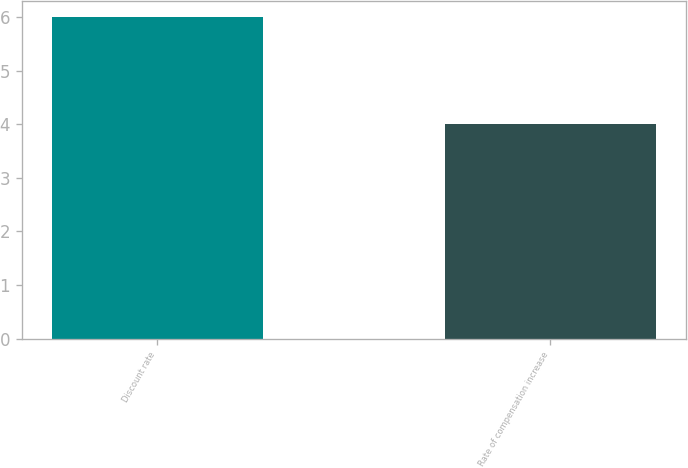<chart> <loc_0><loc_0><loc_500><loc_500><bar_chart><fcel>Discount rate<fcel>Rate of compensation increase<nl><fcel>6<fcel>4<nl></chart> 